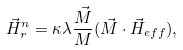Convert formula to latex. <formula><loc_0><loc_0><loc_500><loc_500>\vec { H } _ { r } ^ { n } = { \kappa } { \lambda } \frac { \vec { M } } { M } ( \vec { M } \cdot \vec { H } _ { e f f } ) ,</formula> 